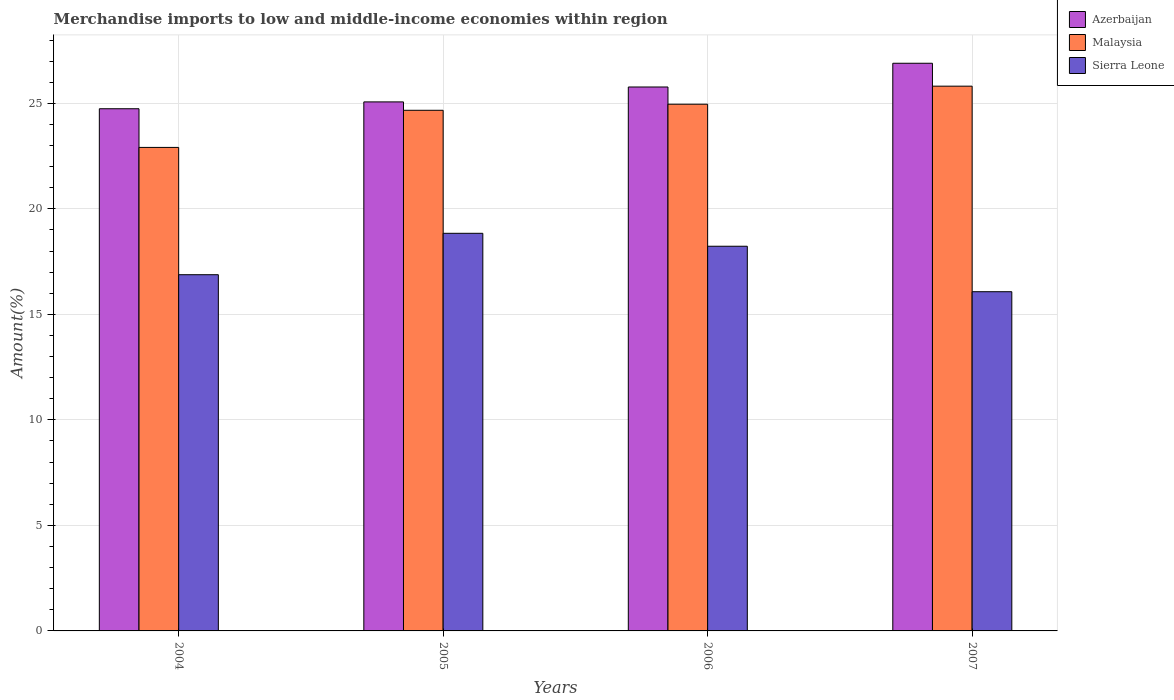How many different coloured bars are there?
Your answer should be very brief. 3. How many groups of bars are there?
Provide a short and direct response. 4. Are the number of bars per tick equal to the number of legend labels?
Provide a succinct answer. Yes. Are the number of bars on each tick of the X-axis equal?
Your answer should be very brief. Yes. What is the label of the 3rd group of bars from the left?
Give a very brief answer. 2006. What is the percentage of amount earned from merchandise imports in Azerbaijan in 2005?
Provide a short and direct response. 25.07. Across all years, what is the maximum percentage of amount earned from merchandise imports in Azerbaijan?
Make the answer very short. 26.9. Across all years, what is the minimum percentage of amount earned from merchandise imports in Sierra Leone?
Ensure brevity in your answer.  16.07. What is the total percentage of amount earned from merchandise imports in Azerbaijan in the graph?
Your response must be concise. 102.48. What is the difference between the percentage of amount earned from merchandise imports in Azerbaijan in 2004 and that in 2005?
Make the answer very short. -0.32. What is the difference between the percentage of amount earned from merchandise imports in Malaysia in 2005 and the percentage of amount earned from merchandise imports in Sierra Leone in 2004?
Ensure brevity in your answer.  7.79. What is the average percentage of amount earned from merchandise imports in Azerbaijan per year?
Ensure brevity in your answer.  25.62. In the year 2006, what is the difference between the percentage of amount earned from merchandise imports in Malaysia and percentage of amount earned from merchandise imports in Sierra Leone?
Make the answer very short. 6.73. In how many years, is the percentage of amount earned from merchandise imports in Sierra Leone greater than 10 %?
Make the answer very short. 4. What is the ratio of the percentage of amount earned from merchandise imports in Azerbaijan in 2006 to that in 2007?
Provide a succinct answer. 0.96. Is the percentage of amount earned from merchandise imports in Azerbaijan in 2005 less than that in 2006?
Provide a short and direct response. Yes. Is the difference between the percentage of amount earned from merchandise imports in Malaysia in 2004 and 2005 greater than the difference between the percentage of amount earned from merchandise imports in Sierra Leone in 2004 and 2005?
Give a very brief answer. Yes. What is the difference between the highest and the second highest percentage of amount earned from merchandise imports in Sierra Leone?
Make the answer very short. 0.61. What is the difference between the highest and the lowest percentage of amount earned from merchandise imports in Azerbaijan?
Your answer should be compact. 2.16. Is the sum of the percentage of amount earned from merchandise imports in Malaysia in 2005 and 2006 greater than the maximum percentage of amount earned from merchandise imports in Azerbaijan across all years?
Your answer should be compact. Yes. What does the 2nd bar from the left in 2007 represents?
Your response must be concise. Malaysia. What does the 3rd bar from the right in 2007 represents?
Your answer should be very brief. Azerbaijan. How many bars are there?
Your answer should be very brief. 12. Are all the bars in the graph horizontal?
Make the answer very short. No. How many years are there in the graph?
Offer a terse response. 4. Are the values on the major ticks of Y-axis written in scientific E-notation?
Your response must be concise. No. Does the graph contain grids?
Make the answer very short. Yes. How many legend labels are there?
Your answer should be very brief. 3. What is the title of the graph?
Offer a terse response. Merchandise imports to low and middle-income economies within region. Does "Malta" appear as one of the legend labels in the graph?
Your answer should be compact. No. What is the label or title of the X-axis?
Make the answer very short. Years. What is the label or title of the Y-axis?
Your response must be concise. Amount(%). What is the Amount(%) in Azerbaijan in 2004?
Offer a terse response. 24.74. What is the Amount(%) of Malaysia in 2004?
Keep it short and to the point. 22.91. What is the Amount(%) in Sierra Leone in 2004?
Make the answer very short. 16.88. What is the Amount(%) of Azerbaijan in 2005?
Make the answer very short. 25.07. What is the Amount(%) in Malaysia in 2005?
Make the answer very short. 24.67. What is the Amount(%) of Sierra Leone in 2005?
Provide a short and direct response. 18.84. What is the Amount(%) of Azerbaijan in 2006?
Your answer should be compact. 25.77. What is the Amount(%) in Malaysia in 2006?
Your response must be concise. 24.96. What is the Amount(%) of Sierra Leone in 2006?
Keep it short and to the point. 18.23. What is the Amount(%) of Azerbaijan in 2007?
Provide a succinct answer. 26.9. What is the Amount(%) in Malaysia in 2007?
Offer a very short reply. 25.81. What is the Amount(%) of Sierra Leone in 2007?
Offer a very short reply. 16.07. Across all years, what is the maximum Amount(%) in Azerbaijan?
Provide a short and direct response. 26.9. Across all years, what is the maximum Amount(%) in Malaysia?
Keep it short and to the point. 25.81. Across all years, what is the maximum Amount(%) of Sierra Leone?
Your response must be concise. 18.84. Across all years, what is the minimum Amount(%) in Azerbaijan?
Ensure brevity in your answer.  24.74. Across all years, what is the minimum Amount(%) in Malaysia?
Ensure brevity in your answer.  22.91. Across all years, what is the minimum Amount(%) of Sierra Leone?
Provide a succinct answer. 16.07. What is the total Amount(%) of Azerbaijan in the graph?
Offer a very short reply. 102.48. What is the total Amount(%) of Malaysia in the graph?
Ensure brevity in your answer.  98.35. What is the total Amount(%) in Sierra Leone in the graph?
Your answer should be very brief. 70.02. What is the difference between the Amount(%) of Azerbaijan in 2004 and that in 2005?
Give a very brief answer. -0.32. What is the difference between the Amount(%) in Malaysia in 2004 and that in 2005?
Offer a terse response. -1.76. What is the difference between the Amount(%) of Sierra Leone in 2004 and that in 2005?
Provide a succinct answer. -1.96. What is the difference between the Amount(%) in Azerbaijan in 2004 and that in 2006?
Make the answer very short. -1.03. What is the difference between the Amount(%) of Malaysia in 2004 and that in 2006?
Give a very brief answer. -2.05. What is the difference between the Amount(%) of Sierra Leone in 2004 and that in 2006?
Keep it short and to the point. -1.35. What is the difference between the Amount(%) in Azerbaijan in 2004 and that in 2007?
Ensure brevity in your answer.  -2.16. What is the difference between the Amount(%) of Malaysia in 2004 and that in 2007?
Offer a very short reply. -2.9. What is the difference between the Amount(%) of Sierra Leone in 2004 and that in 2007?
Ensure brevity in your answer.  0.81. What is the difference between the Amount(%) in Azerbaijan in 2005 and that in 2006?
Your answer should be compact. -0.71. What is the difference between the Amount(%) of Malaysia in 2005 and that in 2006?
Offer a terse response. -0.29. What is the difference between the Amount(%) in Sierra Leone in 2005 and that in 2006?
Provide a short and direct response. 0.61. What is the difference between the Amount(%) in Azerbaijan in 2005 and that in 2007?
Your answer should be compact. -1.83. What is the difference between the Amount(%) in Malaysia in 2005 and that in 2007?
Your response must be concise. -1.14. What is the difference between the Amount(%) in Sierra Leone in 2005 and that in 2007?
Offer a very short reply. 2.77. What is the difference between the Amount(%) in Azerbaijan in 2006 and that in 2007?
Make the answer very short. -1.12. What is the difference between the Amount(%) in Malaysia in 2006 and that in 2007?
Make the answer very short. -0.86. What is the difference between the Amount(%) in Sierra Leone in 2006 and that in 2007?
Your answer should be very brief. 2.15. What is the difference between the Amount(%) in Azerbaijan in 2004 and the Amount(%) in Malaysia in 2005?
Your answer should be very brief. 0.07. What is the difference between the Amount(%) in Azerbaijan in 2004 and the Amount(%) in Sierra Leone in 2005?
Your answer should be compact. 5.9. What is the difference between the Amount(%) of Malaysia in 2004 and the Amount(%) of Sierra Leone in 2005?
Ensure brevity in your answer.  4.07. What is the difference between the Amount(%) in Azerbaijan in 2004 and the Amount(%) in Malaysia in 2006?
Your answer should be very brief. -0.21. What is the difference between the Amount(%) of Azerbaijan in 2004 and the Amount(%) of Sierra Leone in 2006?
Your response must be concise. 6.52. What is the difference between the Amount(%) of Malaysia in 2004 and the Amount(%) of Sierra Leone in 2006?
Provide a succinct answer. 4.68. What is the difference between the Amount(%) in Azerbaijan in 2004 and the Amount(%) in Malaysia in 2007?
Keep it short and to the point. -1.07. What is the difference between the Amount(%) of Azerbaijan in 2004 and the Amount(%) of Sierra Leone in 2007?
Your answer should be very brief. 8.67. What is the difference between the Amount(%) in Malaysia in 2004 and the Amount(%) in Sierra Leone in 2007?
Keep it short and to the point. 6.84. What is the difference between the Amount(%) in Azerbaijan in 2005 and the Amount(%) in Malaysia in 2006?
Your answer should be compact. 0.11. What is the difference between the Amount(%) of Azerbaijan in 2005 and the Amount(%) of Sierra Leone in 2006?
Your answer should be very brief. 6.84. What is the difference between the Amount(%) of Malaysia in 2005 and the Amount(%) of Sierra Leone in 2006?
Provide a succinct answer. 6.44. What is the difference between the Amount(%) in Azerbaijan in 2005 and the Amount(%) in Malaysia in 2007?
Your answer should be compact. -0.75. What is the difference between the Amount(%) in Azerbaijan in 2005 and the Amount(%) in Sierra Leone in 2007?
Keep it short and to the point. 8.99. What is the difference between the Amount(%) of Malaysia in 2005 and the Amount(%) of Sierra Leone in 2007?
Keep it short and to the point. 8.6. What is the difference between the Amount(%) in Azerbaijan in 2006 and the Amount(%) in Malaysia in 2007?
Your answer should be very brief. -0.04. What is the difference between the Amount(%) of Azerbaijan in 2006 and the Amount(%) of Sierra Leone in 2007?
Ensure brevity in your answer.  9.7. What is the difference between the Amount(%) in Malaysia in 2006 and the Amount(%) in Sierra Leone in 2007?
Your response must be concise. 8.88. What is the average Amount(%) in Azerbaijan per year?
Keep it short and to the point. 25.62. What is the average Amount(%) of Malaysia per year?
Keep it short and to the point. 24.59. What is the average Amount(%) of Sierra Leone per year?
Make the answer very short. 17.51. In the year 2004, what is the difference between the Amount(%) in Azerbaijan and Amount(%) in Malaysia?
Give a very brief answer. 1.83. In the year 2004, what is the difference between the Amount(%) in Azerbaijan and Amount(%) in Sierra Leone?
Your answer should be very brief. 7.86. In the year 2004, what is the difference between the Amount(%) of Malaysia and Amount(%) of Sierra Leone?
Make the answer very short. 6.03. In the year 2005, what is the difference between the Amount(%) of Azerbaijan and Amount(%) of Malaysia?
Offer a terse response. 0.4. In the year 2005, what is the difference between the Amount(%) in Azerbaijan and Amount(%) in Sierra Leone?
Provide a short and direct response. 6.23. In the year 2005, what is the difference between the Amount(%) of Malaysia and Amount(%) of Sierra Leone?
Your response must be concise. 5.83. In the year 2006, what is the difference between the Amount(%) in Azerbaijan and Amount(%) in Malaysia?
Your answer should be compact. 0.82. In the year 2006, what is the difference between the Amount(%) in Azerbaijan and Amount(%) in Sierra Leone?
Offer a terse response. 7.55. In the year 2006, what is the difference between the Amount(%) in Malaysia and Amount(%) in Sierra Leone?
Provide a succinct answer. 6.73. In the year 2007, what is the difference between the Amount(%) of Azerbaijan and Amount(%) of Malaysia?
Provide a succinct answer. 1.09. In the year 2007, what is the difference between the Amount(%) of Azerbaijan and Amount(%) of Sierra Leone?
Give a very brief answer. 10.83. In the year 2007, what is the difference between the Amount(%) of Malaysia and Amount(%) of Sierra Leone?
Your answer should be very brief. 9.74. What is the ratio of the Amount(%) of Azerbaijan in 2004 to that in 2005?
Provide a short and direct response. 0.99. What is the ratio of the Amount(%) in Malaysia in 2004 to that in 2005?
Your answer should be very brief. 0.93. What is the ratio of the Amount(%) in Sierra Leone in 2004 to that in 2005?
Ensure brevity in your answer.  0.9. What is the ratio of the Amount(%) in Azerbaijan in 2004 to that in 2006?
Ensure brevity in your answer.  0.96. What is the ratio of the Amount(%) of Malaysia in 2004 to that in 2006?
Provide a short and direct response. 0.92. What is the ratio of the Amount(%) in Sierra Leone in 2004 to that in 2006?
Offer a terse response. 0.93. What is the ratio of the Amount(%) in Azerbaijan in 2004 to that in 2007?
Offer a very short reply. 0.92. What is the ratio of the Amount(%) in Malaysia in 2004 to that in 2007?
Give a very brief answer. 0.89. What is the ratio of the Amount(%) in Sierra Leone in 2004 to that in 2007?
Your answer should be very brief. 1.05. What is the ratio of the Amount(%) of Azerbaijan in 2005 to that in 2006?
Your response must be concise. 0.97. What is the ratio of the Amount(%) in Malaysia in 2005 to that in 2006?
Your response must be concise. 0.99. What is the ratio of the Amount(%) in Sierra Leone in 2005 to that in 2006?
Offer a terse response. 1.03. What is the ratio of the Amount(%) in Azerbaijan in 2005 to that in 2007?
Offer a very short reply. 0.93. What is the ratio of the Amount(%) of Malaysia in 2005 to that in 2007?
Your answer should be very brief. 0.96. What is the ratio of the Amount(%) of Sierra Leone in 2005 to that in 2007?
Provide a succinct answer. 1.17. What is the ratio of the Amount(%) in Azerbaijan in 2006 to that in 2007?
Provide a short and direct response. 0.96. What is the ratio of the Amount(%) of Malaysia in 2006 to that in 2007?
Provide a short and direct response. 0.97. What is the ratio of the Amount(%) of Sierra Leone in 2006 to that in 2007?
Your response must be concise. 1.13. What is the difference between the highest and the second highest Amount(%) in Azerbaijan?
Offer a very short reply. 1.12. What is the difference between the highest and the second highest Amount(%) of Malaysia?
Your answer should be compact. 0.86. What is the difference between the highest and the second highest Amount(%) in Sierra Leone?
Offer a very short reply. 0.61. What is the difference between the highest and the lowest Amount(%) in Azerbaijan?
Provide a succinct answer. 2.16. What is the difference between the highest and the lowest Amount(%) in Malaysia?
Provide a succinct answer. 2.9. What is the difference between the highest and the lowest Amount(%) in Sierra Leone?
Give a very brief answer. 2.77. 